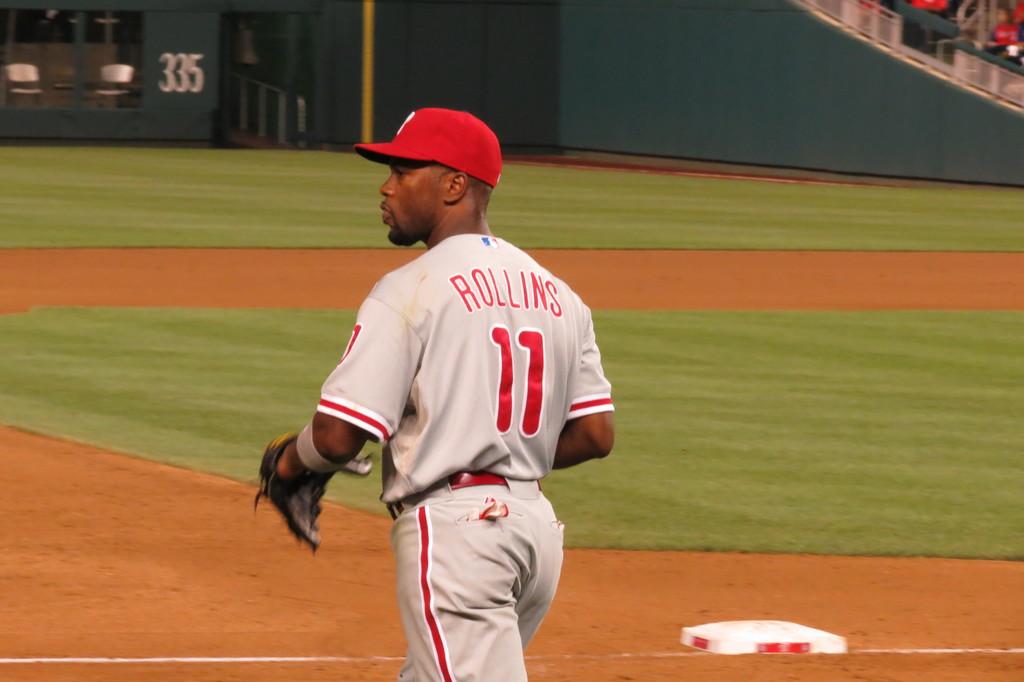What number is on rollins' back?
Your response must be concise. 11. 